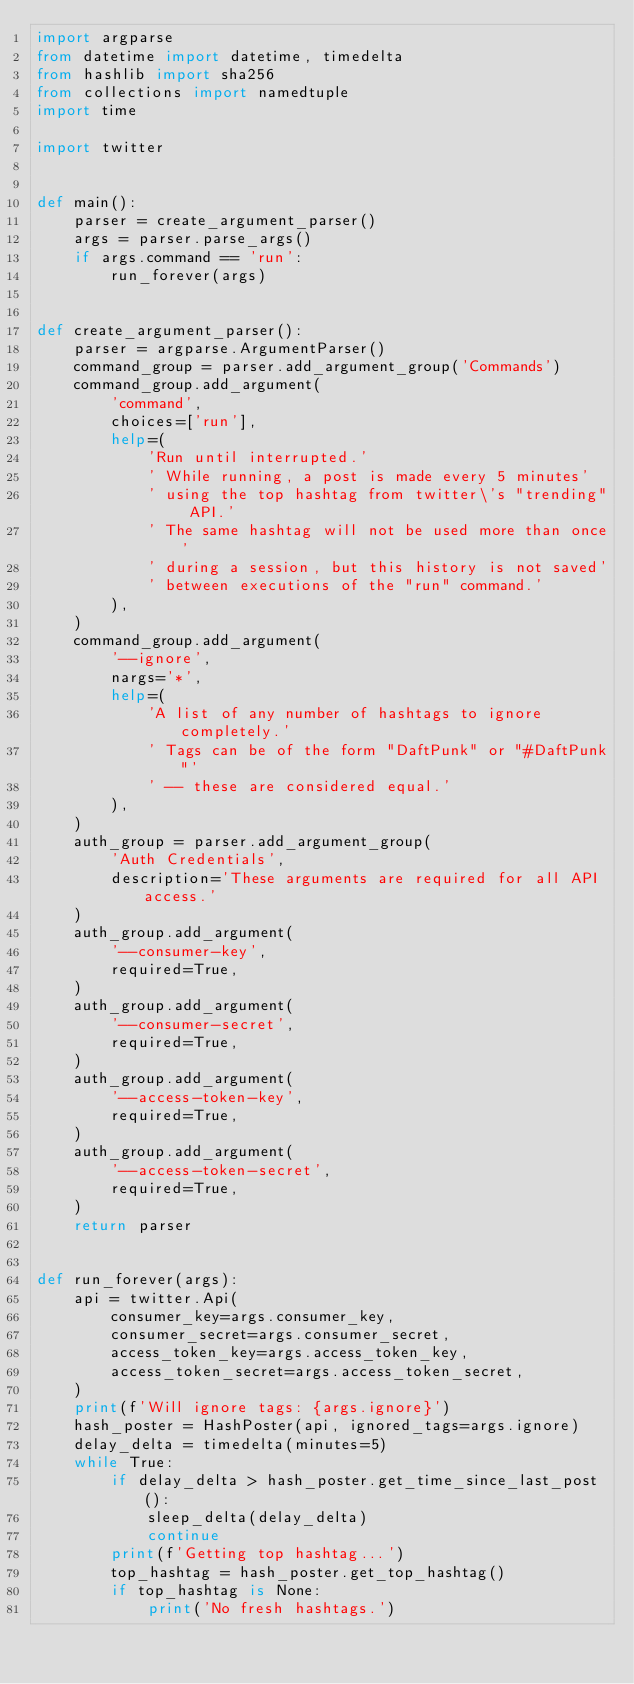<code> <loc_0><loc_0><loc_500><loc_500><_Python_>import argparse
from datetime import datetime, timedelta
from hashlib import sha256
from collections import namedtuple
import time

import twitter


def main():
    parser = create_argument_parser()
    args = parser.parse_args()
    if args.command == 'run':
        run_forever(args)


def create_argument_parser():
    parser = argparse.ArgumentParser()
    command_group = parser.add_argument_group('Commands')
    command_group.add_argument(
        'command',
        choices=['run'],
        help=(
            'Run until interrupted.'
            ' While running, a post is made every 5 minutes'
            ' using the top hashtag from twitter\'s "trending" API.'
            ' The same hashtag will not be used more than once'
            ' during a session, but this history is not saved'
            ' between executions of the "run" command.'
        ),
    )
    command_group.add_argument(
        '--ignore',
        nargs='*',
        help=(
            'A list of any number of hashtags to ignore completely.'
            ' Tags can be of the form "DaftPunk" or "#DaftPunk"'
            ' -- these are considered equal.'
        ),
    )
    auth_group = parser.add_argument_group(
        'Auth Credentials',
        description='These arguments are required for all API access.'
    )
    auth_group.add_argument(
        '--consumer-key',
        required=True,
    )
    auth_group.add_argument(
        '--consumer-secret',
        required=True,
    )
    auth_group.add_argument(
        '--access-token-key',
        required=True,
    )
    auth_group.add_argument(
        '--access-token-secret',
        required=True,
    )
    return parser


def run_forever(args):
    api = twitter.Api(
        consumer_key=args.consumer_key,
        consumer_secret=args.consumer_secret,
        access_token_key=args.access_token_key,
        access_token_secret=args.access_token_secret,
    )
    print(f'Will ignore tags: {args.ignore}')
    hash_poster = HashPoster(api, ignored_tags=args.ignore)
    delay_delta = timedelta(minutes=5)
    while True:
        if delay_delta > hash_poster.get_time_since_last_post():
            sleep_delta(delay_delta)
            continue
        print(f'Getting top hashtag...')
        top_hashtag = hash_poster.get_top_hashtag()
        if top_hashtag is None:
            print('No fresh hashtags.')</code> 